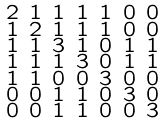<formula> <loc_0><loc_0><loc_500><loc_500>\begin{smallmatrix} 2 & 1 & 1 & 1 & 1 & 0 & 0 \\ 1 & 2 & 1 & 1 & 1 & 0 & 0 \\ 1 & 1 & 3 & 1 & 0 & 1 & 1 \\ 1 & 1 & 1 & 3 & 0 & 1 & 1 \\ 1 & 1 & 0 & 0 & 3 & 0 & 0 \\ 0 & 0 & 1 & 1 & 0 & 3 & 0 \\ 0 & 0 & 1 & 1 & 0 & 0 & 3 \end{smallmatrix}</formula> 